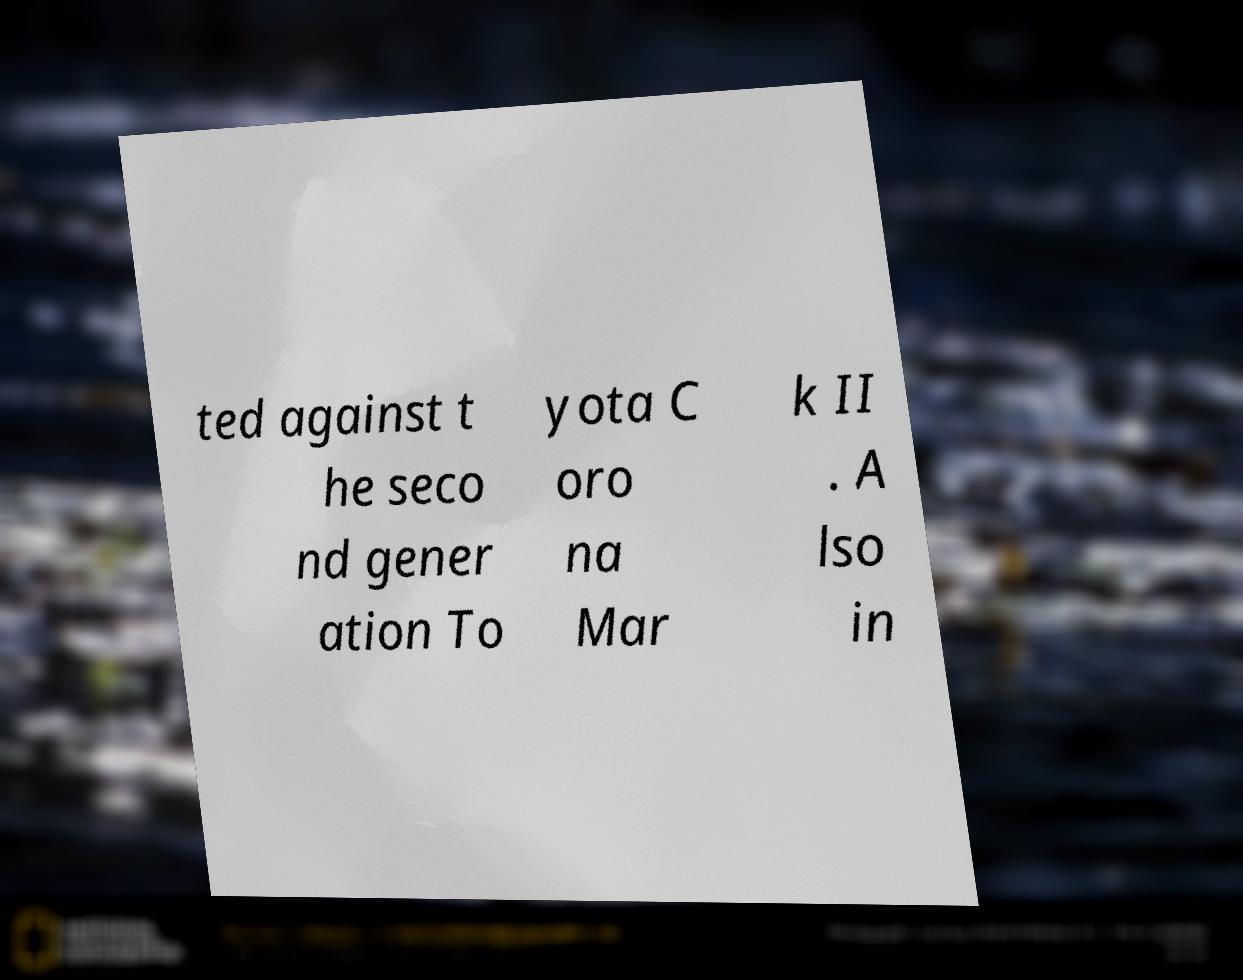Could you assist in decoding the text presented in this image and type it out clearly? ted against t he seco nd gener ation To yota C oro na Mar k II . A lso in 